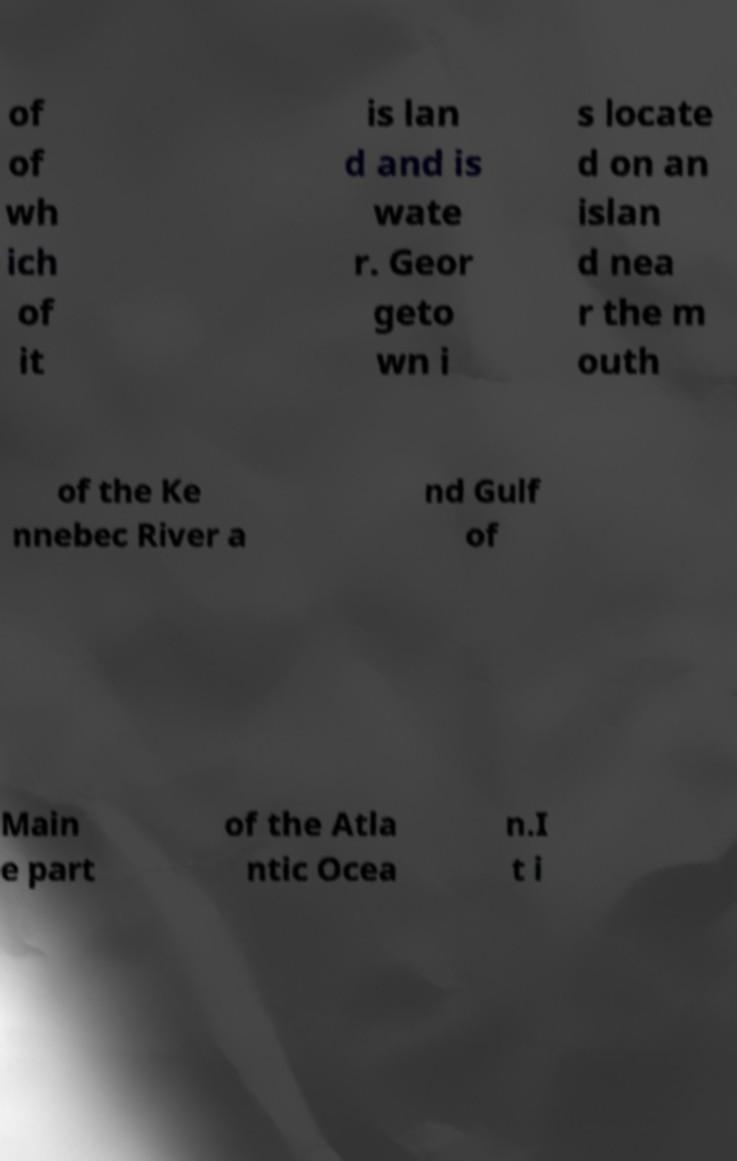Could you assist in decoding the text presented in this image and type it out clearly? of of wh ich of it is lan d and is wate r. Geor geto wn i s locate d on an islan d nea r the m outh of the Ke nnebec River a nd Gulf of Main e part of the Atla ntic Ocea n.I t i 